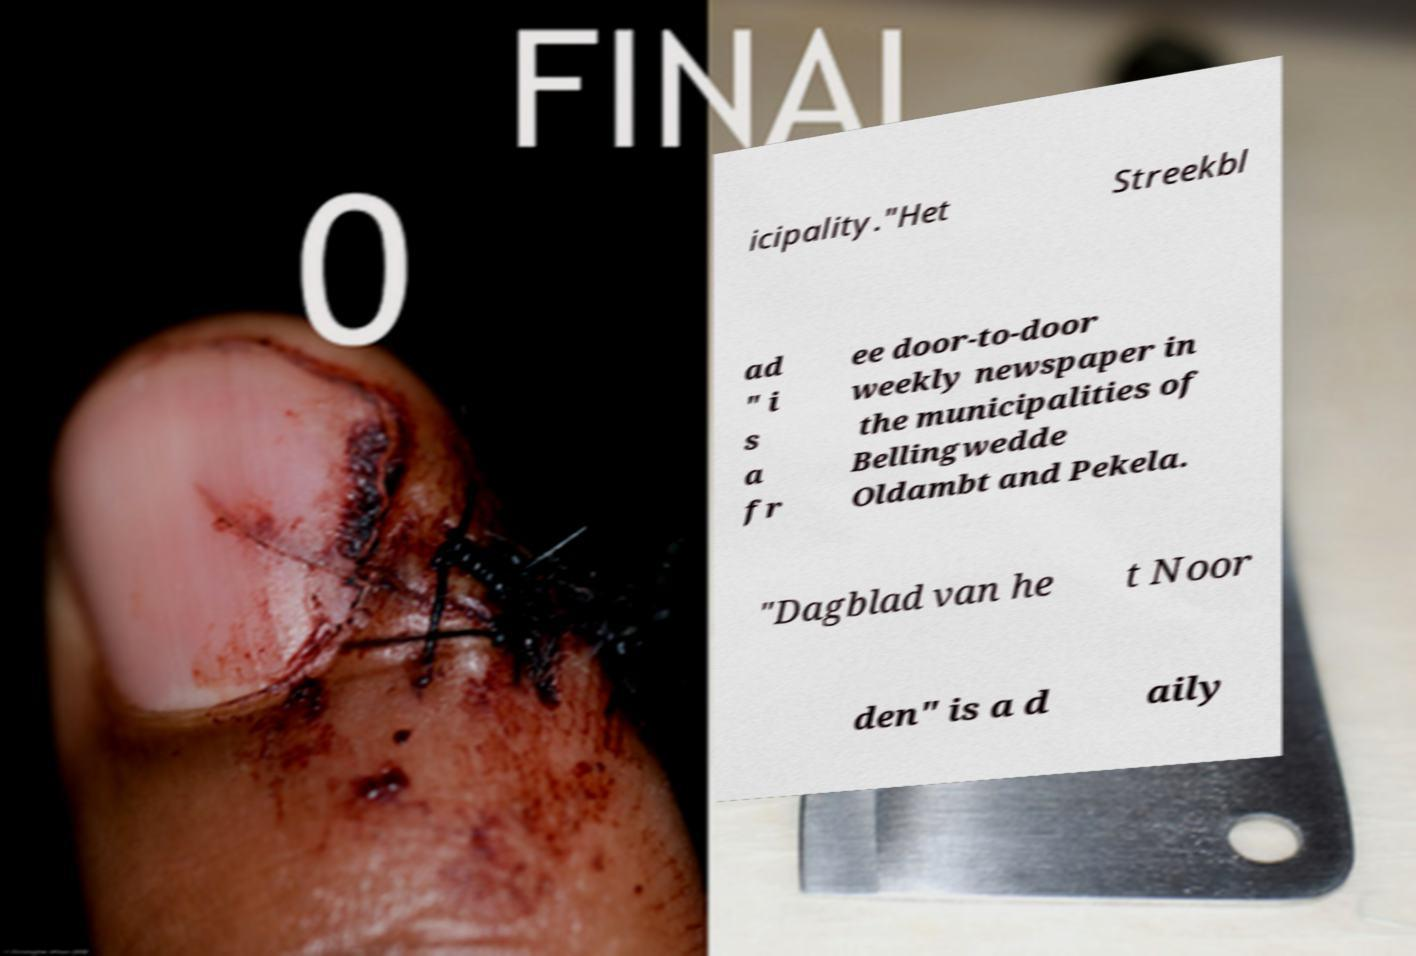What messages or text are displayed in this image? I need them in a readable, typed format. icipality."Het Streekbl ad " i s a fr ee door-to-door weekly newspaper in the municipalities of Bellingwedde Oldambt and Pekela. "Dagblad van he t Noor den" is a d aily 